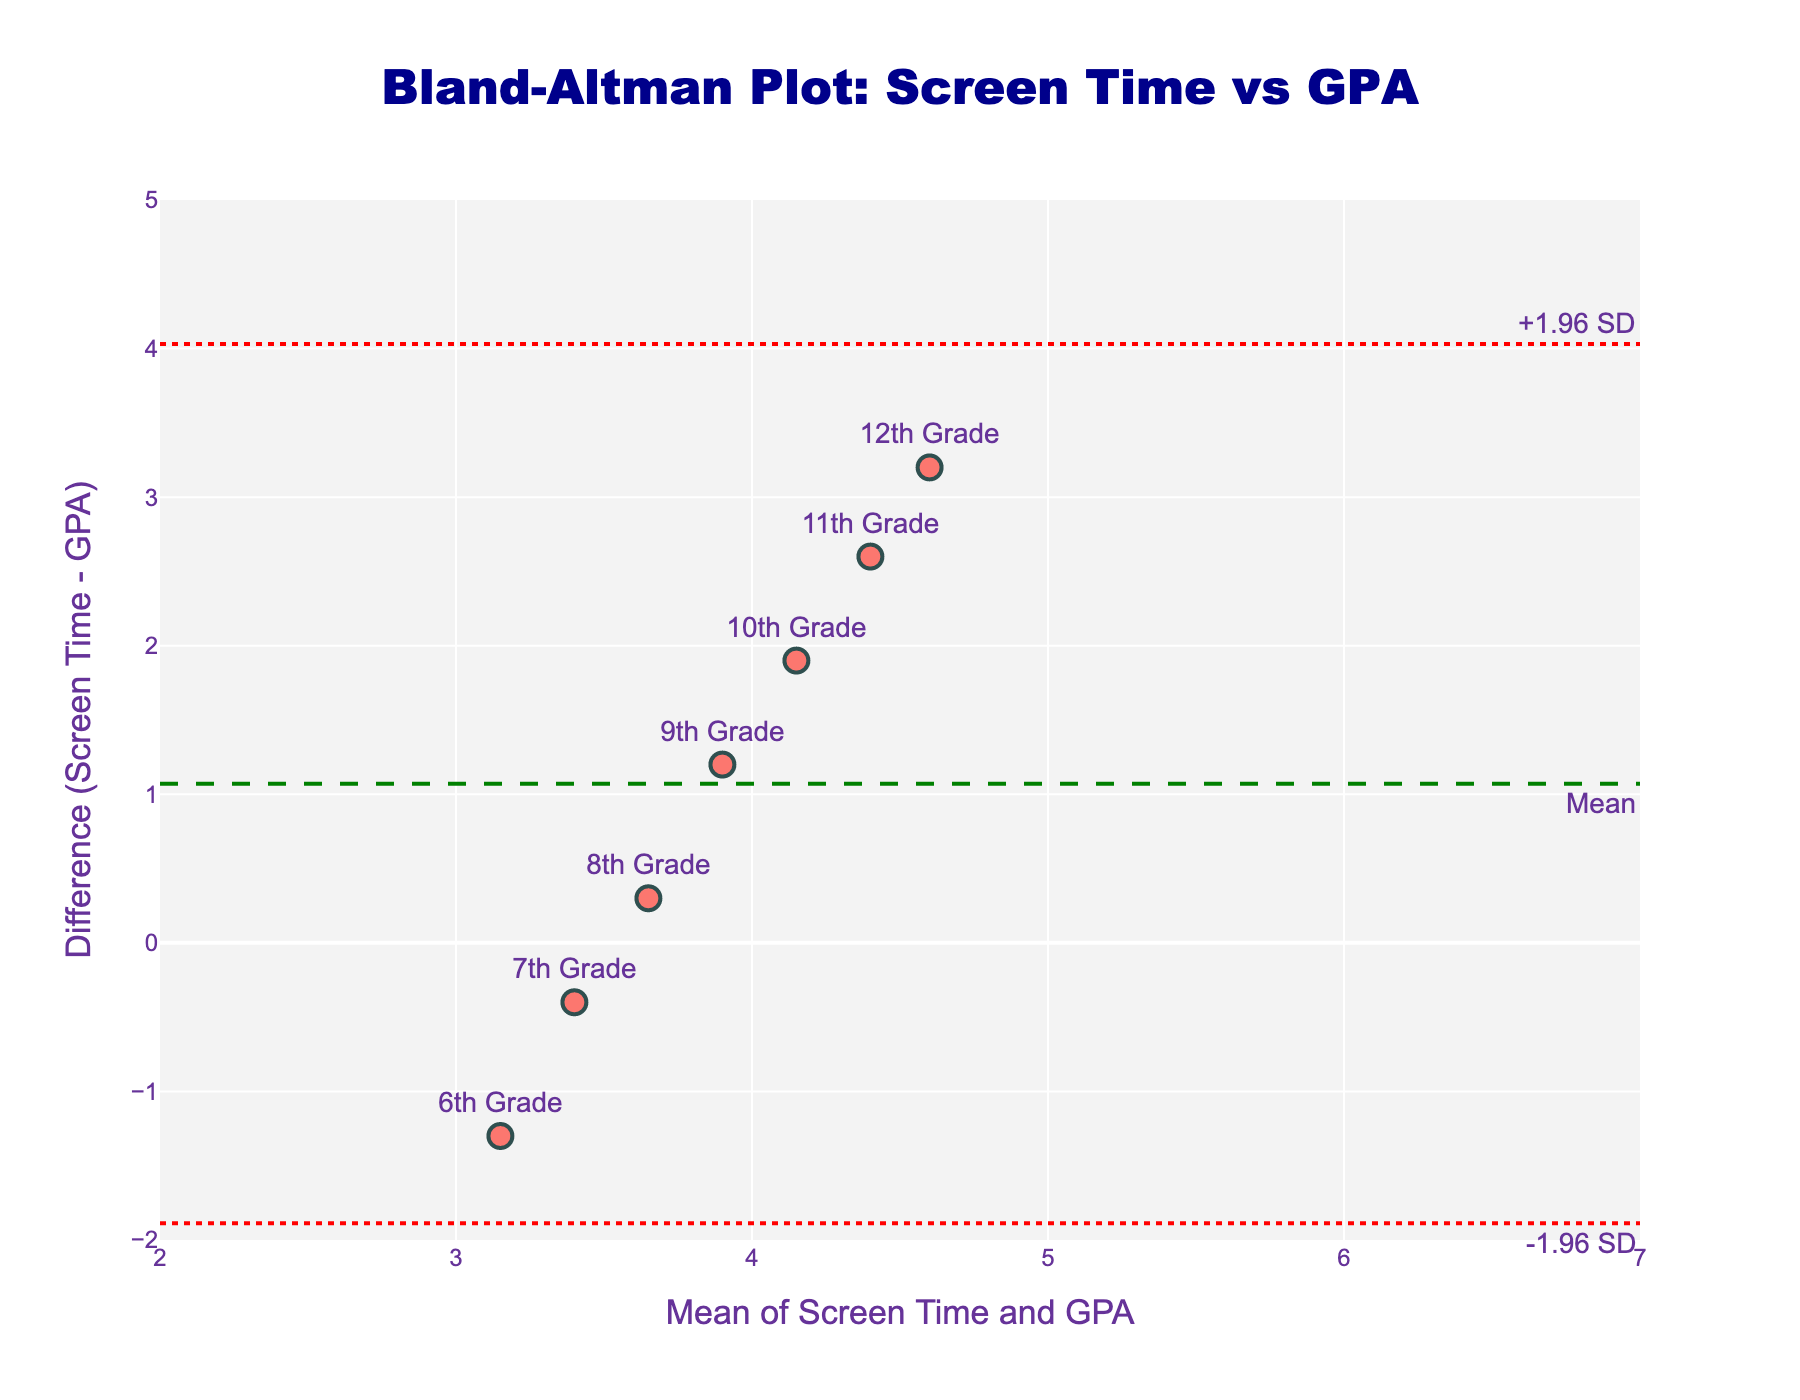What is the title of the plot? The title of the plot is placed prominently at the top and reads, "Bland-Altman Plot: Screen Time vs GPA."
Answer: Bland-Altman Plot: Screen Time vs GPA What does the x-axis represent in the plot? The label on the x-axis indicates that it represents the "Mean of Screen Time and GPA."
Answer: Mean of Screen Time and GPA What does the y-axis represent in the plot? The label on the y-axis shows that it represents the "Difference (Screen Time - GPA)."
Answer: Difference (Screen Time - GPA) How many data points are there in the plot? There are seven grade levels represented in the dataset, so there are seven data points in the plot.
Answer: 7 Which grade level has the highest average daily screen time? By examining the text labels in the scatter plot, we can see that the 12th grade has the highest average daily screen time.
Answer: 12th Grade Which data point has the greatest difference between screen time and GPA? The largest vertical distance from the x-axis shows the greatest difference, and based on text labels, the 12th grade has the greatest difference.
Answer: 12th Grade What is the mean difference (denoted by the green dashed line)? The green dashed line represents the mean difference, and the annotation indicates it is placed slightly above the value 2 on the y-axis.
Answer: Around 1.97 What are the upper and lower limits of agreement? The y-axis has two red dotted lines with annotations. The upper limit is placed around 4.33, denoted as "+1.96 SD," and the lower limit is around -0.39, denoted as "-1.96 SD."
Answer: Around 4.33 and -0.39 How does the average daily screen time affect GPA for higher grades compared to lower grades? Higher grades (e.g., 11th and 12th) have more screen time and lower GPAs, while lower grades (e.g., 6th and 7th) have less screen time and higher GPAs, indicated by their positioning relative to the mean difference.
Answer: More screen time lowers GPA Which grade level's data point is closest to the mean difference line? The mean difference line is closest to the data point for the 7th grade, based on their proximity to the green dashed line.
Answer: 7th Grade 